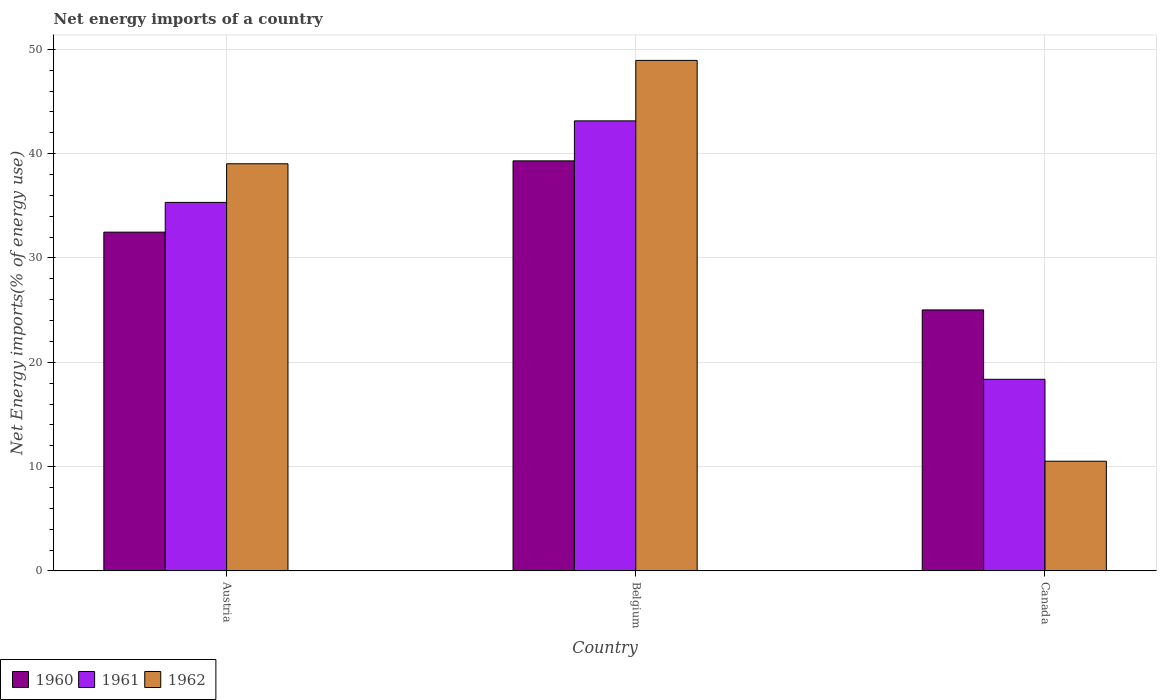How many different coloured bars are there?
Ensure brevity in your answer.  3. How many groups of bars are there?
Your response must be concise. 3. Are the number of bars per tick equal to the number of legend labels?
Your response must be concise. Yes. Are the number of bars on each tick of the X-axis equal?
Ensure brevity in your answer.  Yes. How many bars are there on the 2nd tick from the right?
Ensure brevity in your answer.  3. What is the label of the 2nd group of bars from the left?
Provide a short and direct response. Belgium. What is the net energy imports in 1961 in Belgium?
Your response must be concise. 43.14. Across all countries, what is the maximum net energy imports in 1960?
Give a very brief answer. 39.31. Across all countries, what is the minimum net energy imports in 1961?
Offer a terse response. 18.37. What is the total net energy imports in 1961 in the graph?
Provide a succinct answer. 96.84. What is the difference between the net energy imports in 1961 in Belgium and that in Canada?
Ensure brevity in your answer.  24.78. What is the difference between the net energy imports in 1961 in Austria and the net energy imports in 1962 in Canada?
Your response must be concise. 24.81. What is the average net energy imports in 1960 per country?
Your response must be concise. 32.27. What is the difference between the net energy imports of/in 1962 and net energy imports of/in 1961 in Austria?
Your answer should be very brief. 3.7. What is the ratio of the net energy imports in 1962 in Austria to that in Belgium?
Offer a very short reply. 0.8. What is the difference between the highest and the second highest net energy imports in 1962?
Make the answer very short. 38.43. What is the difference between the highest and the lowest net energy imports in 1962?
Your response must be concise. 38.43. In how many countries, is the net energy imports in 1961 greater than the average net energy imports in 1961 taken over all countries?
Your answer should be compact. 2. Is the sum of the net energy imports in 1961 in Belgium and Canada greater than the maximum net energy imports in 1960 across all countries?
Your answer should be very brief. Yes. What does the 2nd bar from the left in Belgium represents?
Your response must be concise. 1961. What does the 2nd bar from the right in Austria represents?
Keep it short and to the point. 1961. Is it the case that in every country, the sum of the net energy imports in 1962 and net energy imports in 1961 is greater than the net energy imports in 1960?
Keep it short and to the point. Yes. Are the values on the major ticks of Y-axis written in scientific E-notation?
Offer a terse response. No. Does the graph contain any zero values?
Keep it short and to the point. No. Where does the legend appear in the graph?
Offer a very short reply. Bottom left. What is the title of the graph?
Your answer should be very brief. Net energy imports of a country. Does "1993" appear as one of the legend labels in the graph?
Provide a short and direct response. No. What is the label or title of the Y-axis?
Your answer should be very brief. Net Energy imports(% of energy use). What is the Net Energy imports(% of energy use) of 1960 in Austria?
Make the answer very short. 32.48. What is the Net Energy imports(% of energy use) in 1961 in Austria?
Give a very brief answer. 35.33. What is the Net Energy imports(% of energy use) of 1962 in Austria?
Keep it short and to the point. 39.03. What is the Net Energy imports(% of energy use) in 1960 in Belgium?
Your answer should be compact. 39.31. What is the Net Energy imports(% of energy use) in 1961 in Belgium?
Make the answer very short. 43.14. What is the Net Energy imports(% of energy use) of 1962 in Belgium?
Ensure brevity in your answer.  48.94. What is the Net Energy imports(% of energy use) of 1960 in Canada?
Provide a succinct answer. 25.02. What is the Net Energy imports(% of energy use) in 1961 in Canada?
Make the answer very short. 18.37. What is the Net Energy imports(% of energy use) of 1962 in Canada?
Your answer should be very brief. 10.52. Across all countries, what is the maximum Net Energy imports(% of energy use) of 1960?
Make the answer very short. 39.31. Across all countries, what is the maximum Net Energy imports(% of energy use) of 1961?
Ensure brevity in your answer.  43.14. Across all countries, what is the maximum Net Energy imports(% of energy use) of 1962?
Ensure brevity in your answer.  48.94. Across all countries, what is the minimum Net Energy imports(% of energy use) of 1960?
Give a very brief answer. 25.02. Across all countries, what is the minimum Net Energy imports(% of energy use) in 1961?
Give a very brief answer. 18.37. Across all countries, what is the minimum Net Energy imports(% of energy use) in 1962?
Keep it short and to the point. 10.52. What is the total Net Energy imports(% of energy use) of 1960 in the graph?
Your answer should be compact. 96.8. What is the total Net Energy imports(% of energy use) in 1961 in the graph?
Make the answer very short. 96.84. What is the total Net Energy imports(% of energy use) of 1962 in the graph?
Make the answer very short. 98.49. What is the difference between the Net Energy imports(% of energy use) of 1960 in Austria and that in Belgium?
Offer a terse response. -6.83. What is the difference between the Net Energy imports(% of energy use) of 1961 in Austria and that in Belgium?
Keep it short and to the point. -7.82. What is the difference between the Net Energy imports(% of energy use) in 1962 in Austria and that in Belgium?
Provide a short and direct response. -9.91. What is the difference between the Net Energy imports(% of energy use) in 1960 in Austria and that in Canada?
Keep it short and to the point. 7.46. What is the difference between the Net Energy imports(% of energy use) in 1961 in Austria and that in Canada?
Provide a succinct answer. 16.96. What is the difference between the Net Energy imports(% of energy use) in 1962 in Austria and that in Canada?
Ensure brevity in your answer.  28.52. What is the difference between the Net Energy imports(% of energy use) of 1960 in Belgium and that in Canada?
Provide a succinct answer. 14.29. What is the difference between the Net Energy imports(% of energy use) of 1961 in Belgium and that in Canada?
Give a very brief answer. 24.78. What is the difference between the Net Energy imports(% of energy use) in 1962 in Belgium and that in Canada?
Your answer should be very brief. 38.43. What is the difference between the Net Energy imports(% of energy use) of 1960 in Austria and the Net Energy imports(% of energy use) of 1961 in Belgium?
Provide a succinct answer. -10.67. What is the difference between the Net Energy imports(% of energy use) of 1960 in Austria and the Net Energy imports(% of energy use) of 1962 in Belgium?
Offer a terse response. -16.46. What is the difference between the Net Energy imports(% of energy use) of 1961 in Austria and the Net Energy imports(% of energy use) of 1962 in Belgium?
Make the answer very short. -13.61. What is the difference between the Net Energy imports(% of energy use) of 1960 in Austria and the Net Energy imports(% of energy use) of 1961 in Canada?
Keep it short and to the point. 14.11. What is the difference between the Net Energy imports(% of energy use) in 1960 in Austria and the Net Energy imports(% of energy use) in 1962 in Canada?
Keep it short and to the point. 21.96. What is the difference between the Net Energy imports(% of energy use) in 1961 in Austria and the Net Energy imports(% of energy use) in 1962 in Canada?
Give a very brief answer. 24.81. What is the difference between the Net Energy imports(% of energy use) of 1960 in Belgium and the Net Energy imports(% of energy use) of 1961 in Canada?
Your response must be concise. 20.94. What is the difference between the Net Energy imports(% of energy use) of 1960 in Belgium and the Net Energy imports(% of energy use) of 1962 in Canada?
Provide a succinct answer. 28.79. What is the difference between the Net Energy imports(% of energy use) of 1961 in Belgium and the Net Energy imports(% of energy use) of 1962 in Canada?
Ensure brevity in your answer.  32.63. What is the average Net Energy imports(% of energy use) of 1960 per country?
Offer a very short reply. 32.27. What is the average Net Energy imports(% of energy use) in 1961 per country?
Give a very brief answer. 32.28. What is the average Net Energy imports(% of energy use) of 1962 per country?
Provide a short and direct response. 32.83. What is the difference between the Net Energy imports(% of energy use) in 1960 and Net Energy imports(% of energy use) in 1961 in Austria?
Your answer should be compact. -2.85. What is the difference between the Net Energy imports(% of energy use) of 1960 and Net Energy imports(% of energy use) of 1962 in Austria?
Keep it short and to the point. -6.55. What is the difference between the Net Energy imports(% of energy use) in 1961 and Net Energy imports(% of energy use) in 1962 in Austria?
Provide a short and direct response. -3.7. What is the difference between the Net Energy imports(% of energy use) in 1960 and Net Energy imports(% of energy use) in 1961 in Belgium?
Your answer should be compact. -3.83. What is the difference between the Net Energy imports(% of energy use) in 1960 and Net Energy imports(% of energy use) in 1962 in Belgium?
Provide a short and direct response. -9.63. What is the difference between the Net Energy imports(% of energy use) of 1961 and Net Energy imports(% of energy use) of 1962 in Belgium?
Your answer should be very brief. -5.8. What is the difference between the Net Energy imports(% of energy use) in 1960 and Net Energy imports(% of energy use) in 1961 in Canada?
Your response must be concise. 6.65. What is the difference between the Net Energy imports(% of energy use) in 1960 and Net Energy imports(% of energy use) in 1962 in Canada?
Offer a terse response. 14.5. What is the difference between the Net Energy imports(% of energy use) of 1961 and Net Energy imports(% of energy use) of 1962 in Canada?
Offer a very short reply. 7.85. What is the ratio of the Net Energy imports(% of energy use) of 1960 in Austria to that in Belgium?
Make the answer very short. 0.83. What is the ratio of the Net Energy imports(% of energy use) of 1961 in Austria to that in Belgium?
Provide a succinct answer. 0.82. What is the ratio of the Net Energy imports(% of energy use) in 1962 in Austria to that in Belgium?
Offer a terse response. 0.8. What is the ratio of the Net Energy imports(% of energy use) of 1960 in Austria to that in Canada?
Ensure brevity in your answer.  1.3. What is the ratio of the Net Energy imports(% of energy use) in 1961 in Austria to that in Canada?
Keep it short and to the point. 1.92. What is the ratio of the Net Energy imports(% of energy use) of 1962 in Austria to that in Canada?
Provide a short and direct response. 3.71. What is the ratio of the Net Energy imports(% of energy use) in 1960 in Belgium to that in Canada?
Ensure brevity in your answer.  1.57. What is the ratio of the Net Energy imports(% of energy use) in 1961 in Belgium to that in Canada?
Provide a short and direct response. 2.35. What is the ratio of the Net Energy imports(% of energy use) of 1962 in Belgium to that in Canada?
Make the answer very short. 4.65. What is the difference between the highest and the second highest Net Energy imports(% of energy use) of 1960?
Your response must be concise. 6.83. What is the difference between the highest and the second highest Net Energy imports(% of energy use) of 1961?
Your answer should be compact. 7.82. What is the difference between the highest and the second highest Net Energy imports(% of energy use) in 1962?
Ensure brevity in your answer.  9.91. What is the difference between the highest and the lowest Net Energy imports(% of energy use) of 1960?
Offer a very short reply. 14.29. What is the difference between the highest and the lowest Net Energy imports(% of energy use) of 1961?
Make the answer very short. 24.78. What is the difference between the highest and the lowest Net Energy imports(% of energy use) in 1962?
Your answer should be compact. 38.43. 